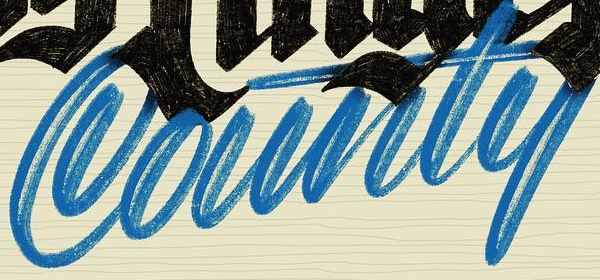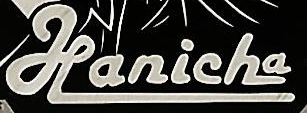What text is displayed in these images sequentially, separated by a semicolon? County; Hanicha 